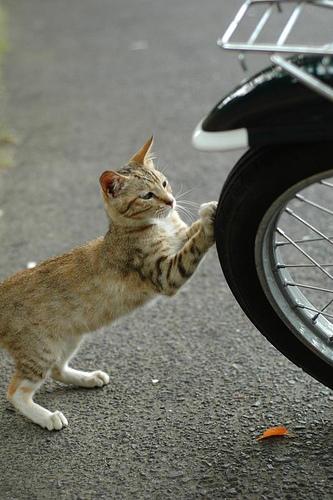What type of vehicle is pictured?
Short answer required. Motorcycle. Is the cat scratching the tire?
Concise answer only. Yes. What is the cat doing?
Quick response, please. Scratching. 